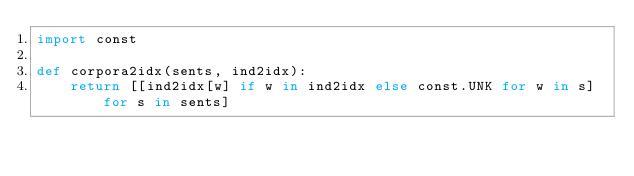Convert code to text. <code><loc_0><loc_0><loc_500><loc_500><_Python_>import const

def corpora2idx(sents, ind2idx):
    return [[ind2idx[w] if w in ind2idx else const.UNK for w in s] for s in sents]

</code> 